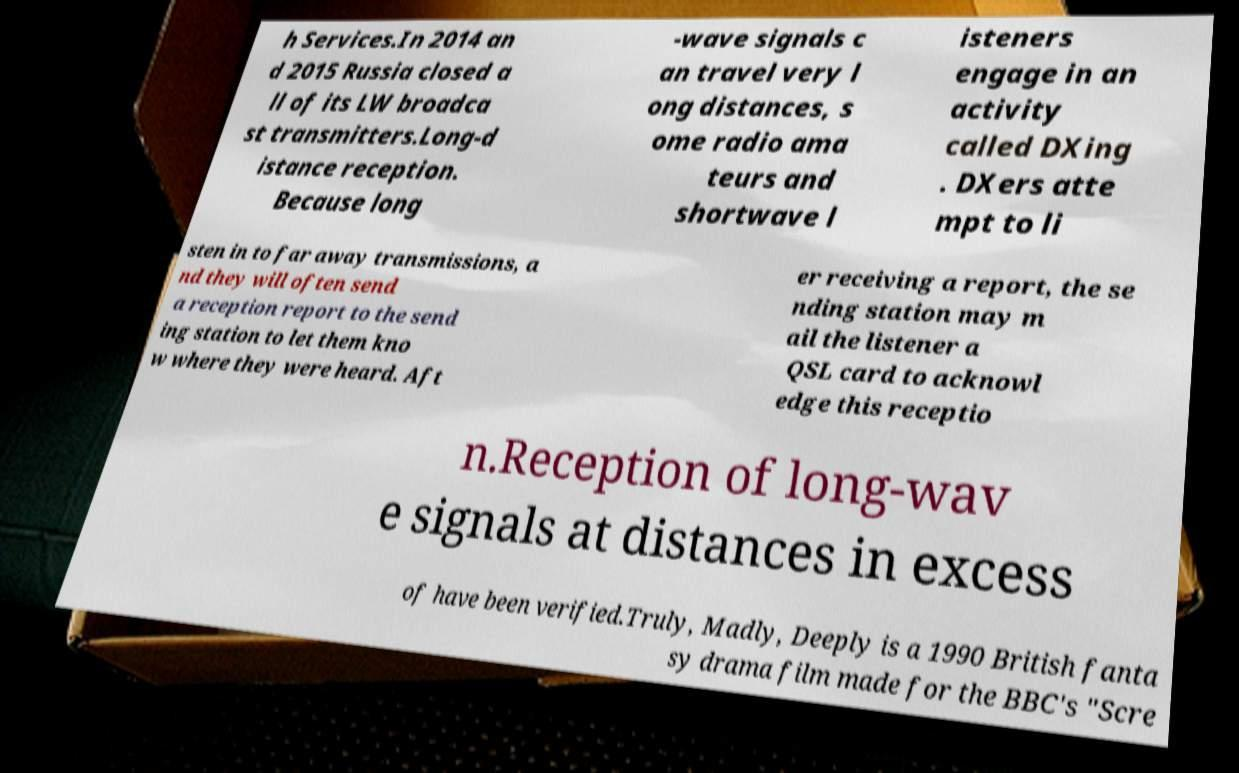Please identify and transcribe the text found in this image. h Services.In 2014 an d 2015 Russia closed a ll of its LW broadca st transmitters.Long-d istance reception. Because long -wave signals c an travel very l ong distances, s ome radio ama teurs and shortwave l isteners engage in an activity called DXing . DXers atte mpt to li sten in to far away transmissions, a nd they will often send a reception report to the send ing station to let them kno w where they were heard. Aft er receiving a report, the se nding station may m ail the listener a QSL card to acknowl edge this receptio n.Reception of long-wav e signals at distances in excess of have been verified.Truly, Madly, Deeply is a 1990 British fanta sy drama film made for the BBC's "Scre 